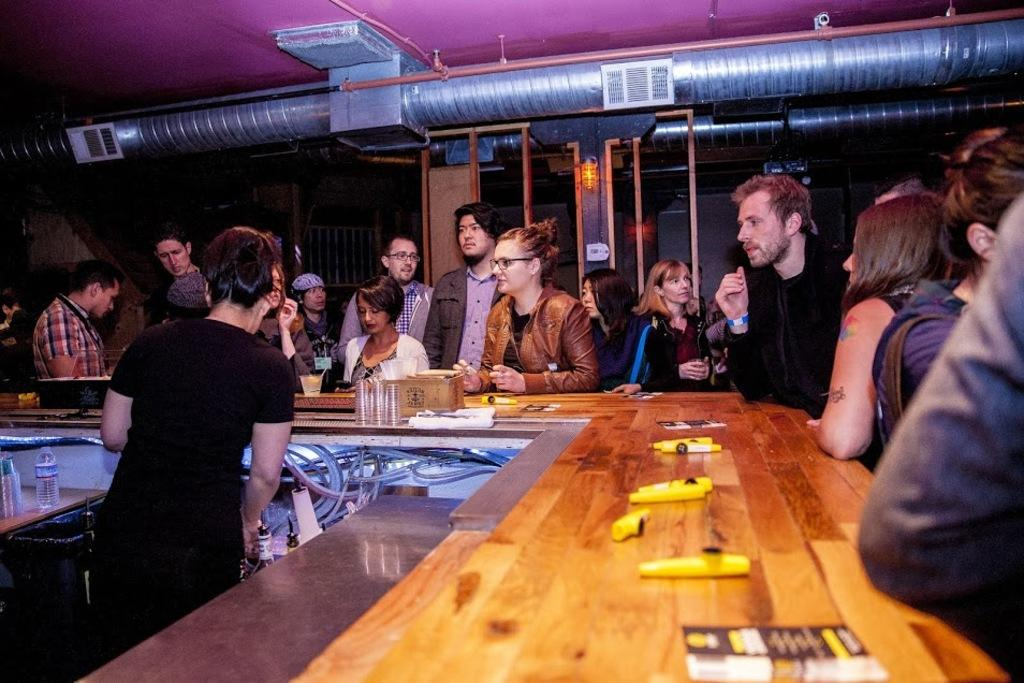How many people are in the image? There is a group of people in the image. Where are the people located in relation to the desk? The group of people is standing near a desk. What can be found on the desk? There are some things on the desk. Can you describe the position of the guy in the image? There is a guy on the other side of the desk. What type of popcorn is being served on the desk? There is no popcorn present in the image. How many cents are visible on the desk? There is no mention of currency or cents in the image. 